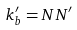<formula> <loc_0><loc_0><loc_500><loc_500>k ^ { \prime } _ { b } = N N ^ { \prime }</formula> 